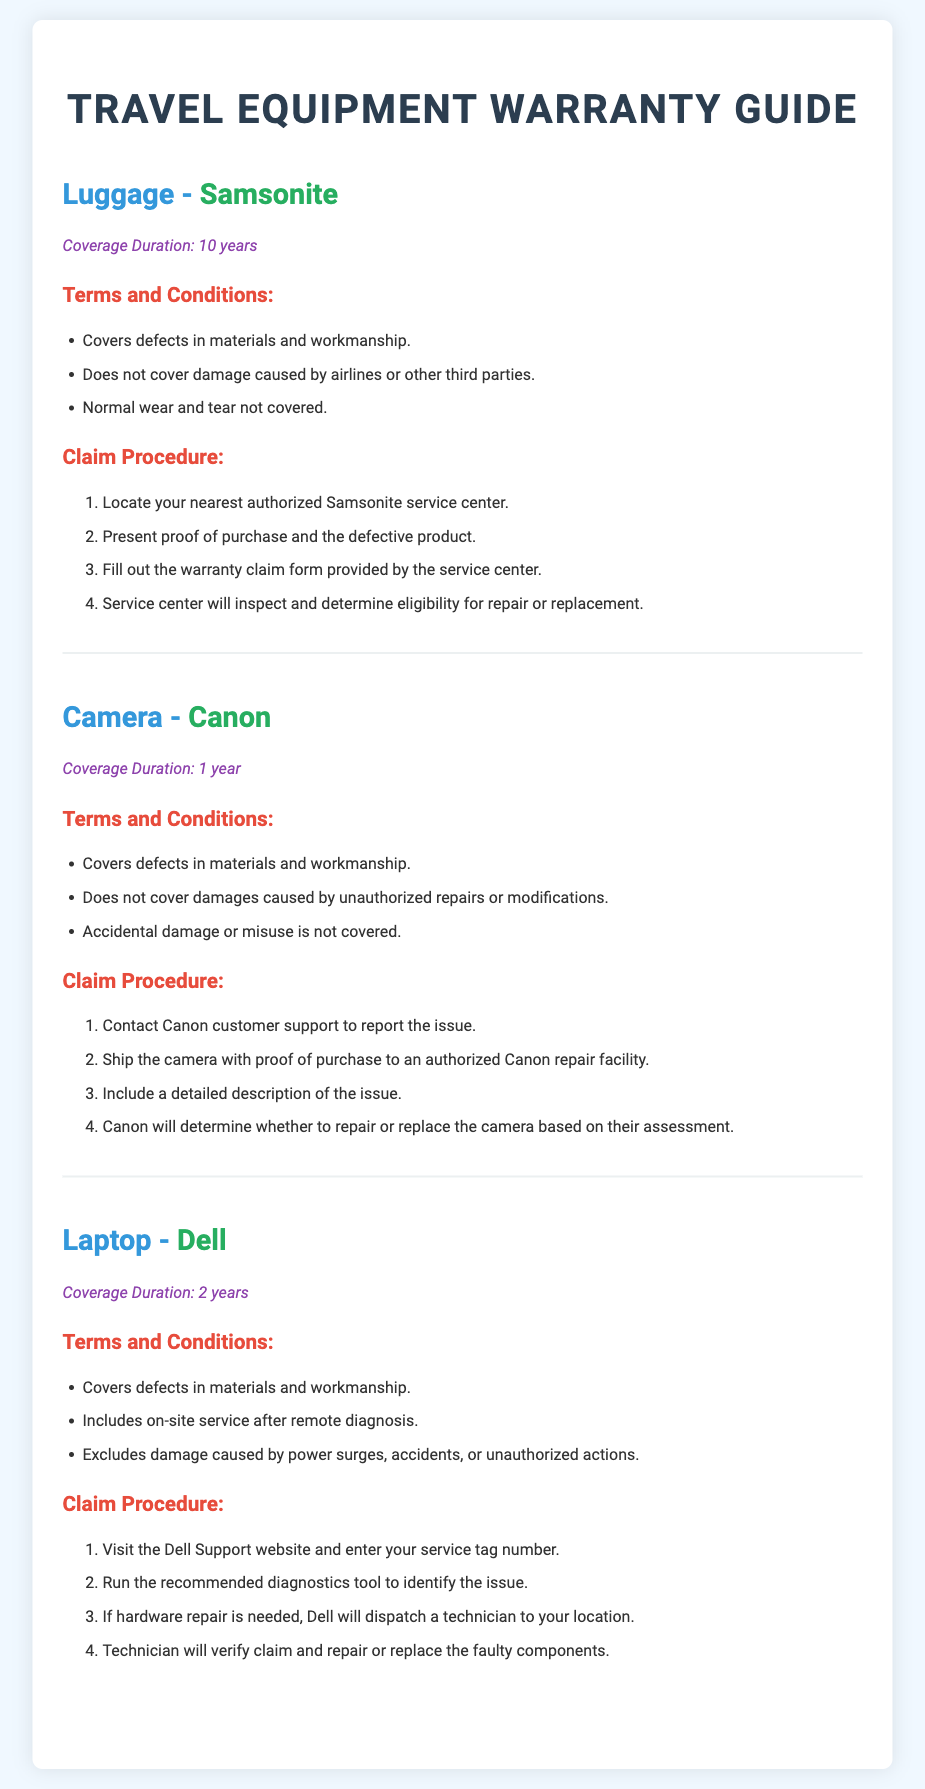What is the coverage duration for luggage by Samsonite? The coverage duration for luggage by Samsonite is mentioned in the document as 10 years.
Answer: 10 years What is the coverage duration for a Canon camera? The document states that the coverage duration for a Canon camera is 1 year.
Answer: 1 year What should you include when shipping a camera to Canon for repair? The document specifies that you should include a detailed description of the issue when shipping a camera to Canon.
Answer: A detailed description of the issue What is excluded from Dell's warranty coverage? The document lists that damage caused by power surges, accidents, or unauthorized actions is excluded from Dell's warranty coverage.
Answer: Damage caused by power surges, accidents, or unauthorized actions What is the first step in the claim procedure for Samsonite luggage? The document mentions that the first step in the claim procedure for Samsonite luggage is to locate your nearest authorized Samsonite service center.
Answer: Locate your nearest authorized Samsonite service center Which brand's warranty lasts for 2 years? The document states that the warranty for Dell laptops lasts for 2 years.
Answer: Dell What type of damage does Canon's warranty not cover? The document specifies that accidental damage or misuse is not covered by Canon's warranty.
Answer: Accidental damage or misuse How can you initiate a claim for a Dell laptop? The document indicates that you can initiate a claim for a Dell laptop by visiting the Dell Support website and entering your service tag number.
Answer: Visit the Dell Support website and enter your service tag number 